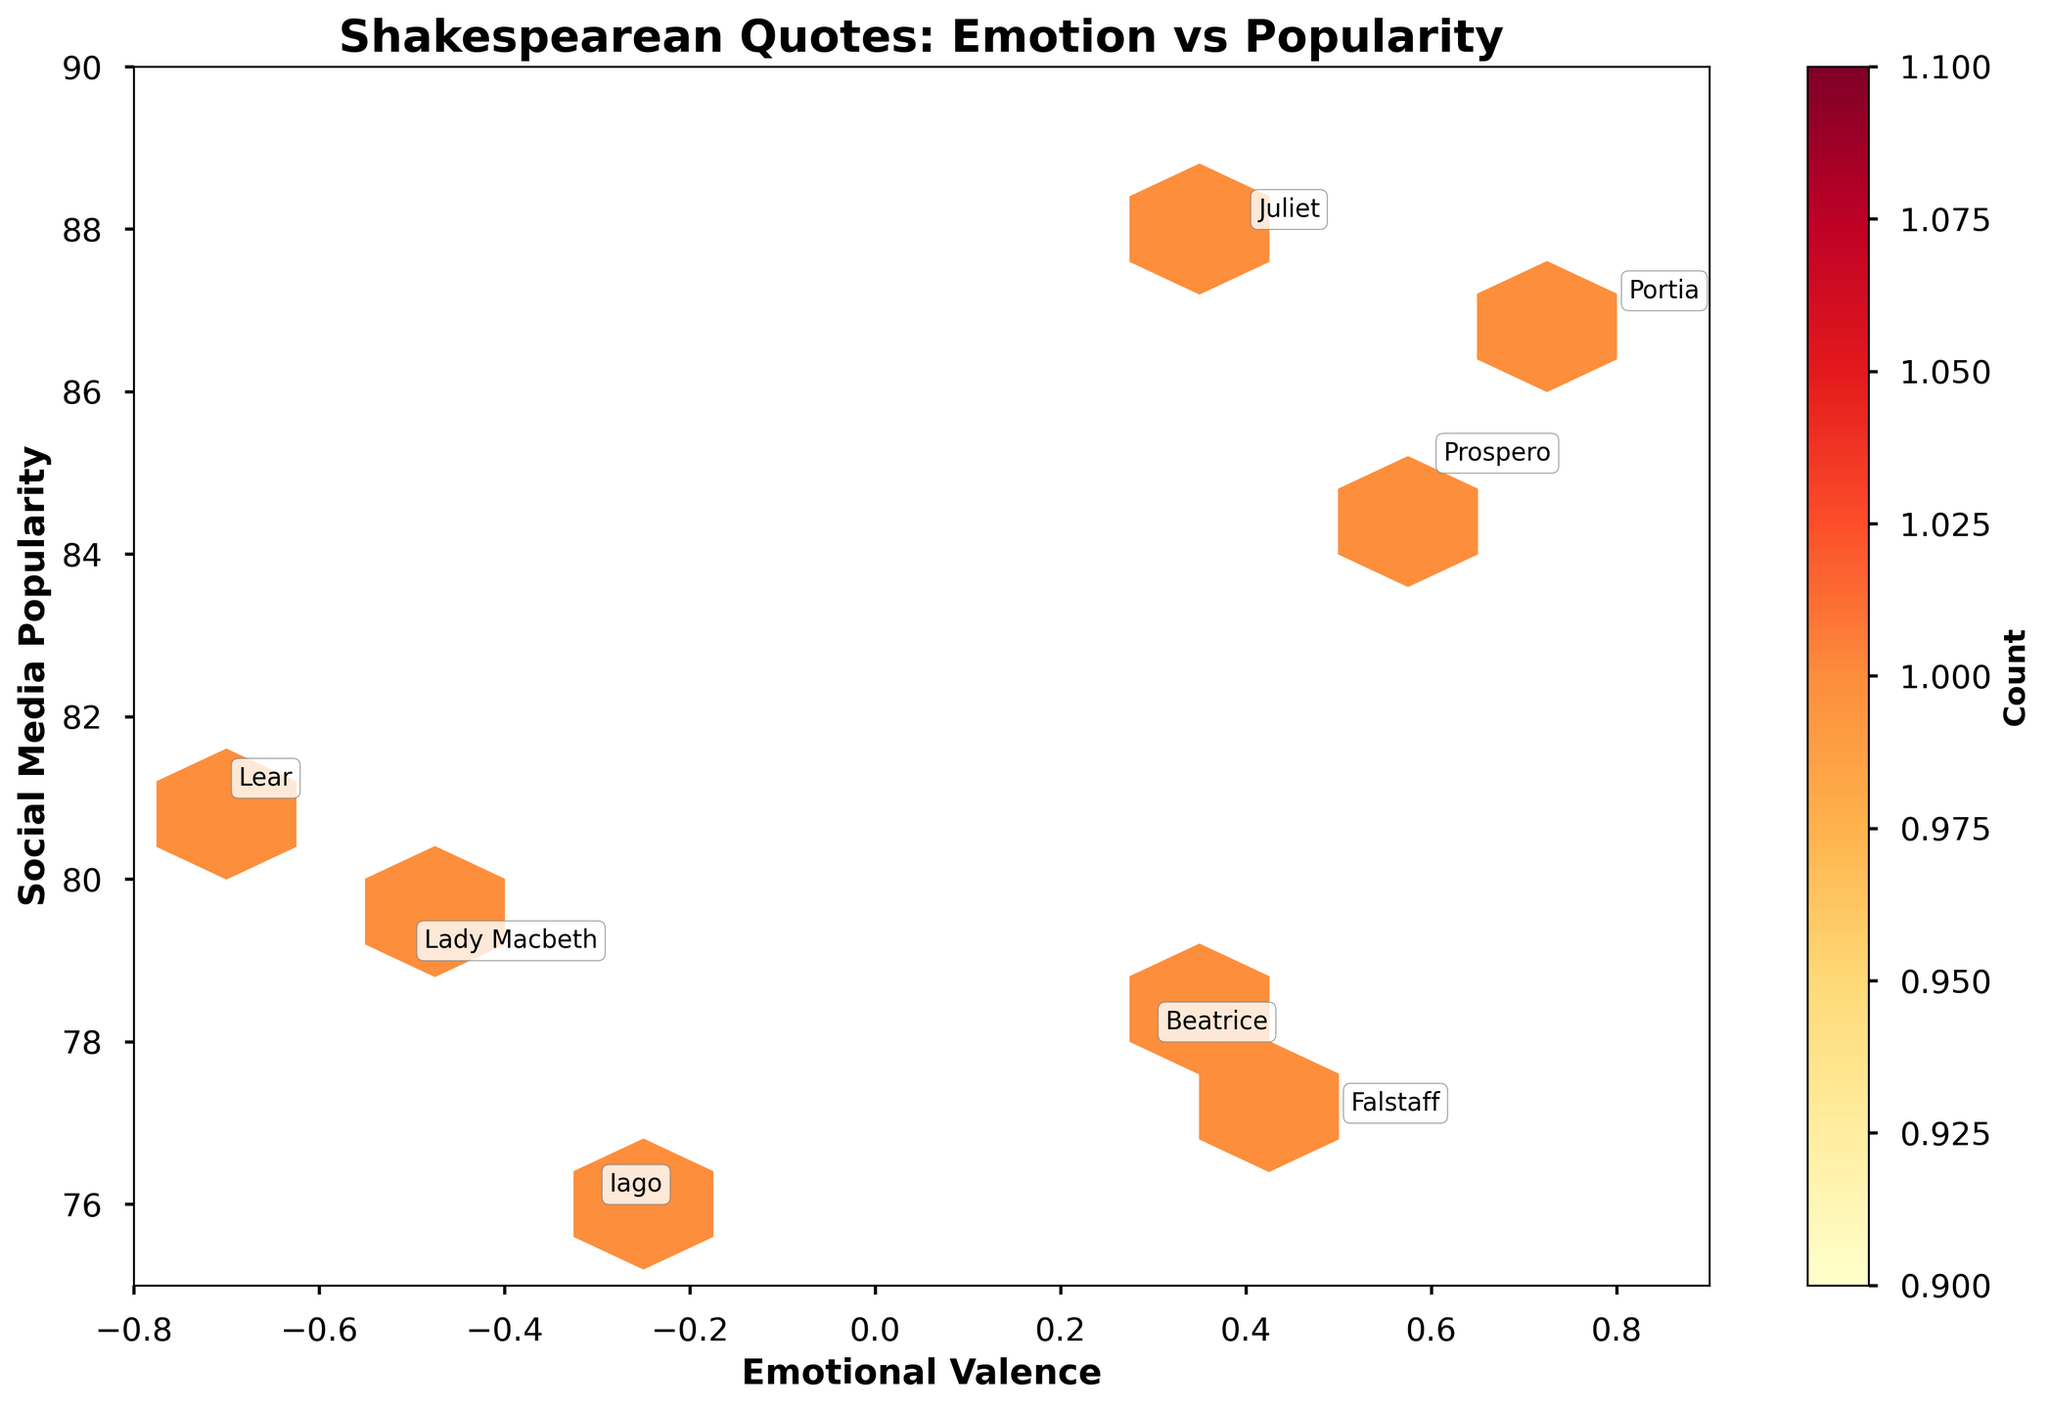what is the title of the plot? The title is usually displayed at the top of the plot. In this case, it states the overall theme or intent of the plot.
Answer: Shakespearean Quotes: Emotion vs Popularity What are the limits of the x-axis? The x-axis, titled "Emotional Valence", spans from -0.8 to 0.9. This range is evident by observing the leftmost and rightmost values along the x-axis.
Answer: -0.8 to 0.9 Which character has the highest social media popularity? By looking at the labels associated with the highest y-axis value (Social Media Popularity), we see that Juliet has the highest popularity with a value of 88.
Answer: Juliet What is the emotional valence of Lady Macbeth's quote? The emotional valence is displayed on the x-axis. By finding Lady Macbeth's label on the plot, her quote's valence is -0.5.
Answer: -0.5 How many hexagonal bins contain data points? The hexbin plot visual uses colored hexagons to represent data. By counting these hexagons, we can answer the question. There are 4 hexagons with data points.
Answer: 4 Which character's quote has the lowest emotional valence and what is its popularity? By scanning for the lowest value on the x-axis and identifying the annotated character, Lear's quote is the lowest with an emotional valence of -0.7 and a popularity of 81.
Answer: Lear, 81 What is the relationship between emotional valence and social media popularity? In examining the spread and density of data points from left to right, and correlating the x and y values, it appears there is no strong correlation as points are spread across the plot.
Answer: No strong correlation Which play has the character with the highest emotional valence quote? By finding the point with the highest emotional valence on the x-axis and noting the character, we see that Portia from "The Merchant of Venice" has the highest emotional valence of 0.8.
Answer: The Merchant of Venice Are quotes with negative emotional valence less popular than those with positive valence? Evaluating the plot, negative emotional valence quotes are clustered between 76 and 81 on the y-axis, while positive valence quotes range from 77 to 88. On average, positive valence quotes are more popular, but it's not a strict rule.
Answer: Generally yes Is there a character with a quote that has a middle-range valence (around 0)? What is their quote's popularity? By identifying points near zero on the x-axis, Beatrice with a valence of 0.3 is a candidate, and her associated popularity is 78.
Answer: Yes, Beatrice, 78 